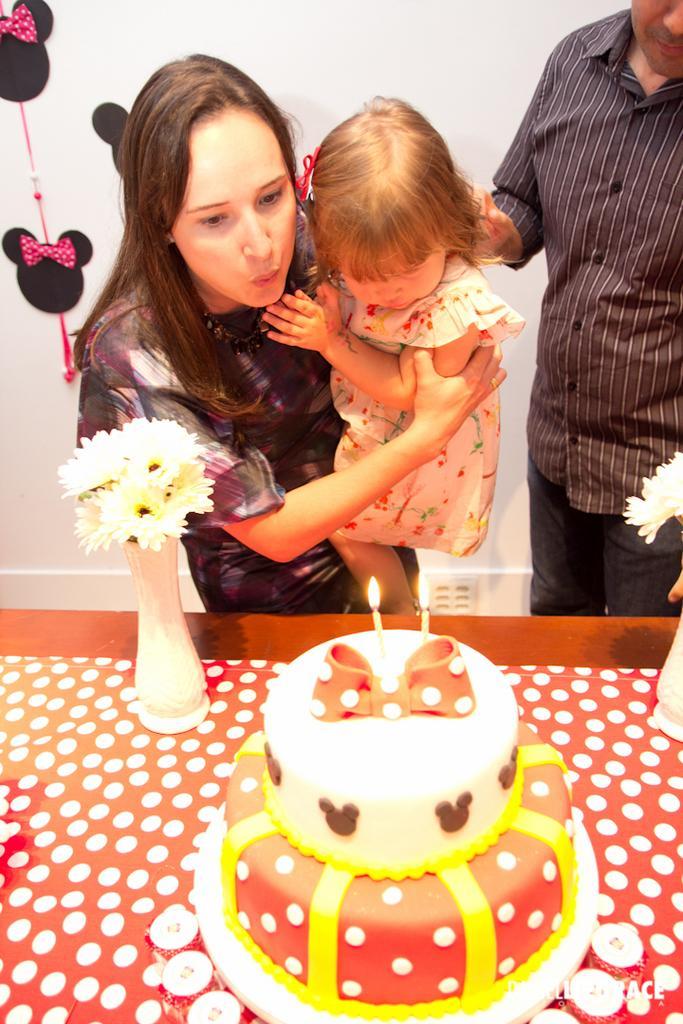Could you give a brief overview of what you see in this image? In the picture we can see a table on it, we can see a cake with two candles on it with light and near to the table, we can see a woman standing and holding a small baby and beside her we can see a man standing and in the background we can see a wall with some craft design on it. 